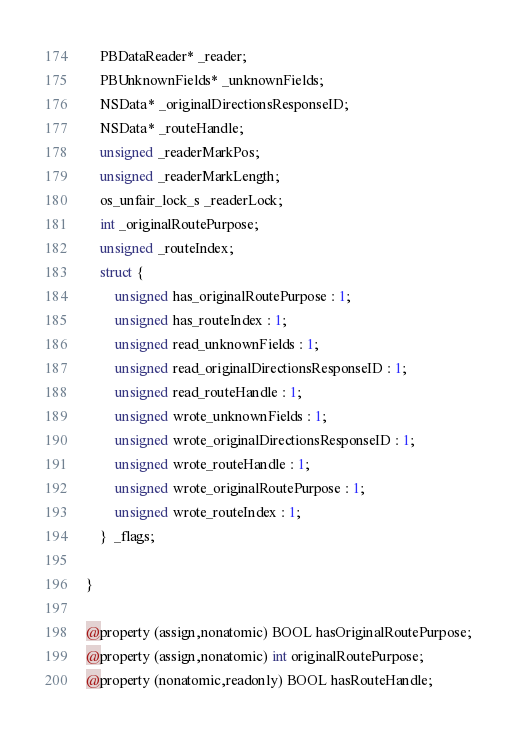<code> <loc_0><loc_0><loc_500><loc_500><_C_>	PBDataReader* _reader;
	PBUnknownFields* _unknownFields;
	NSData* _originalDirectionsResponseID;
	NSData* _routeHandle;
	unsigned _readerMarkPos;
	unsigned _readerMarkLength;
	os_unfair_lock_s _readerLock;
	int _originalRoutePurpose;
	unsigned _routeIndex;
	struct {
		unsigned has_originalRoutePurpose : 1;
		unsigned has_routeIndex : 1;
		unsigned read_unknownFields : 1;
		unsigned read_originalDirectionsResponseID : 1;
		unsigned read_routeHandle : 1;
		unsigned wrote_unknownFields : 1;
		unsigned wrote_originalDirectionsResponseID : 1;
		unsigned wrote_routeHandle : 1;
		unsigned wrote_originalRoutePurpose : 1;
		unsigned wrote_routeIndex : 1;
	}  _flags;

}

@property (assign,nonatomic) BOOL hasOriginalRoutePurpose; 
@property (assign,nonatomic) int originalRoutePurpose; 
@property (nonatomic,readonly) BOOL hasRouteHandle; </code> 